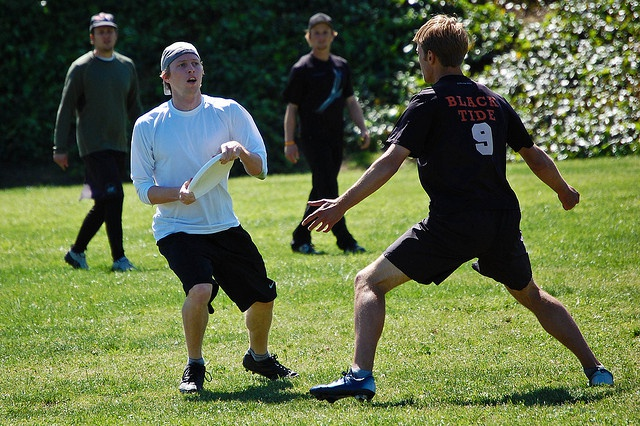Describe the objects in this image and their specific colors. I can see people in black, maroon, gray, and olive tones, people in black, darkgray, and gray tones, people in black, gray, blue, and maroon tones, people in black, maroon, and gray tones, and frisbee in black, darkgray, olive, and lightblue tones in this image. 